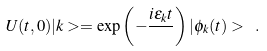Convert formula to latex. <formula><loc_0><loc_0><loc_500><loc_500>U ( t , 0 ) | k > = \exp \left ( - \frac { i \epsilon _ { k } t } { } \right ) | \phi _ { k } ( t ) > \ .</formula> 